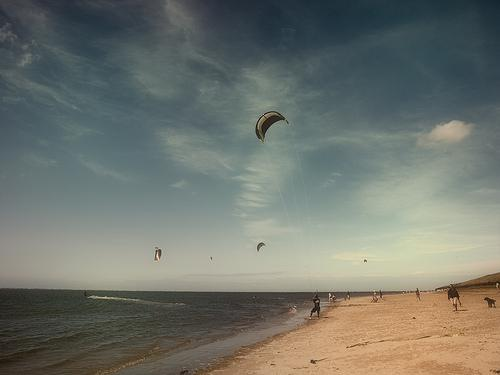Question: what time of day is it?
Choices:
A. Morning.
B. Evening.
C. Afternoon.
D. Dusk.
Answer with the letter. Answer: B Question: what is in the sky?
Choices:
A. Balloons.
B. Kites.
C. Japanese lanterns.
D. Clouds.
Answer with the letter. Answer: B Question: what are the people doing?
Choices:
A. Flying kites.
B. Parasailing.
C. Hang gliding.
D. Bungee jumping.
Answer with the letter. Answer: A Question: who is on the beach?
Choices:
A. Surfers.
B. People.
C. Children.
D. Campers.
Answer with the letter. Answer: B Question: where are the people at?
Choices:
A. Beach.
B. Mountaintop.
C. Desert.
D. City sidewalk.
Answer with the letter. Answer: A Question: what color is the water?
Choices:
A. Blue.
B. Gray.
C. Green.
D. Black.
Answer with the letter. Answer: B 